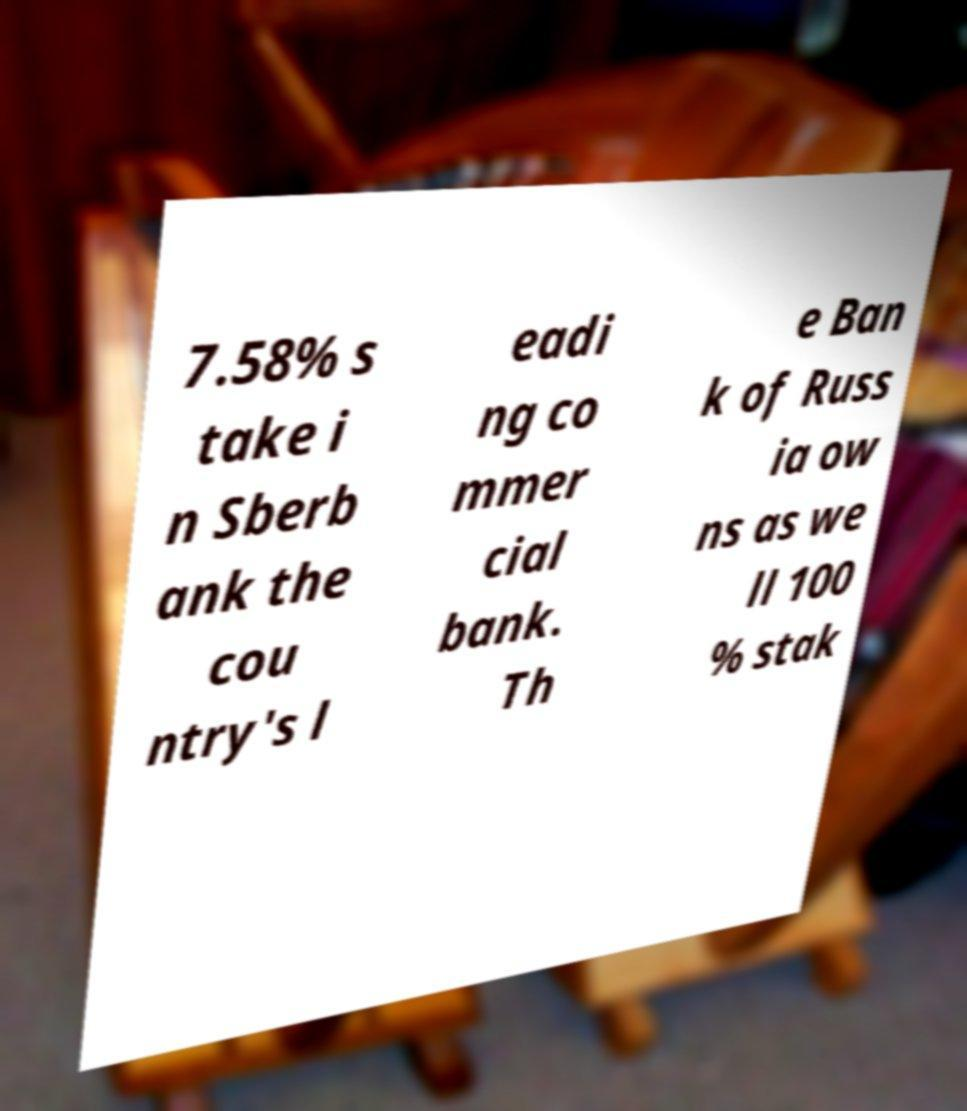I need the written content from this picture converted into text. Can you do that? 7.58% s take i n Sberb ank the cou ntry's l eadi ng co mmer cial bank. Th e Ban k of Russ ia ow ns as we ll 100 % stak 